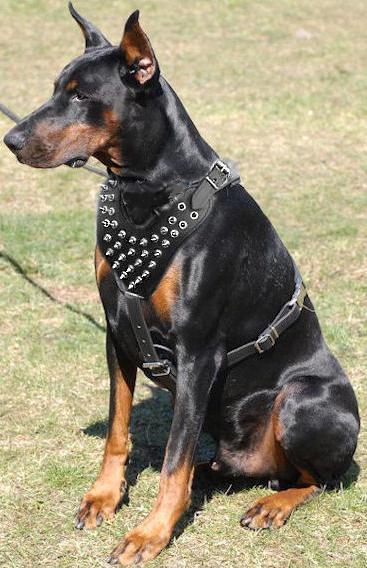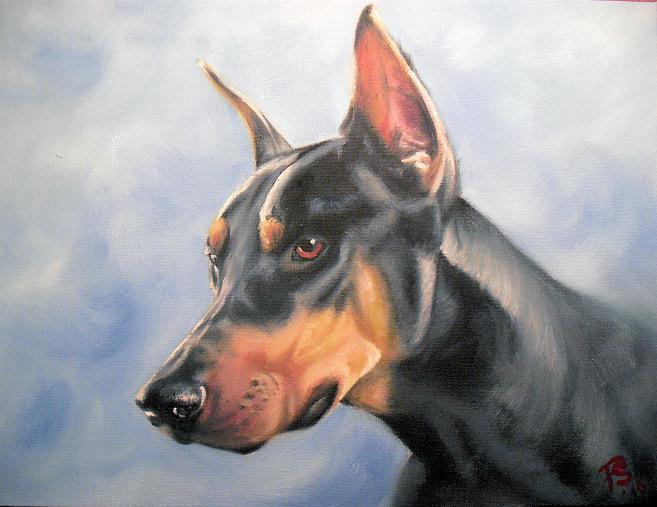The first image is the image on the left, the second image is the image on the right. Analyze the images presented: Is the assertion "The dog in the image on the left is wearing a collar and hanging its tongue out." valid? Answer yes or no. No. The first image is the image on the left, the second image is the image on the right. For the images shown, is this caption "Each image features one adult doberman with erect ears and upright head, and the dog on the left wears something spiky around its neck." true? Answer yes or no. Yes. 